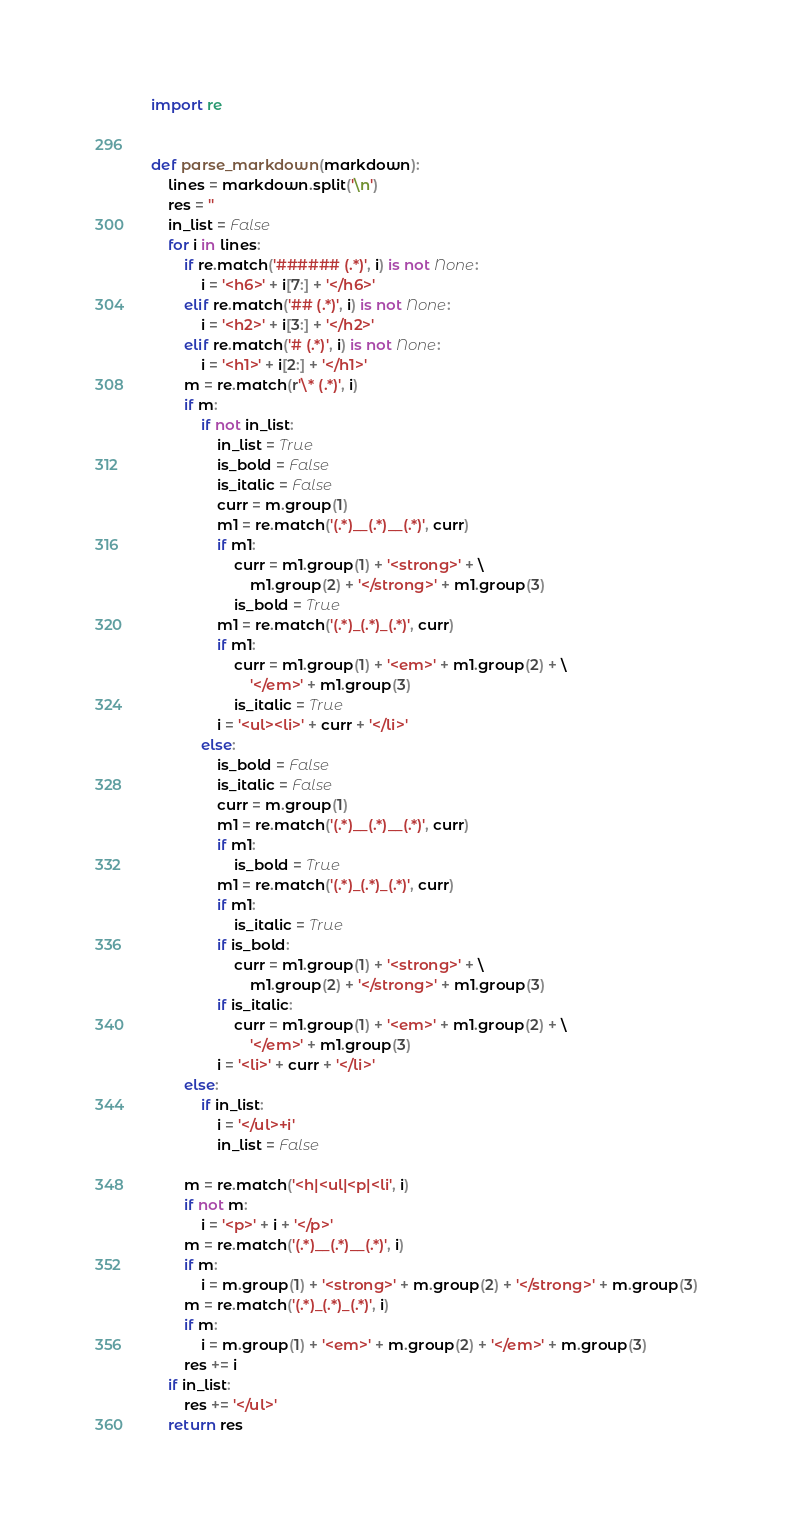Convert code to text. <code><loc_0><loc_0><loc_500><loc_500><_Python_>import re


def parse_markdown(markdown):
    lines = markdown.split('\n')
    res = ''
    in_list = False
    for i in lines:
        if re.match('###### (.*)', i) is not None:
            i = '<h6>' + i[7:] + '</h6>'
        elif re.match('## (.*)', i) is not None:
            i = '<h2>' + i[3:] + '</h2>'
        elif re.match('# (.*)', i) is not None:
            i = '<h1>' + i[2:] + '</h1>'
        m = re.match(r'\* (.*)', i)
        if m:
            if not in_list:
                in_list = True
                is_bold = False
                is_italic = False
                curr = m.group(1)
                m1 = re.match('(.*)__(.*)__(.*)', curr)
                if m1:
                    curr = m1.group(1) + '<strong>' + \
                        m1.group(2) + '</strong>' + m1.group(3)
                    is_bold = True
                m1 = re.match('(.*)_(.*)_(.*)', curr)
                if m1:
                    curr = m1.group(1) + '<em>' + m1.group(2) + \
                        '</em>' + m1.group(3)
                    is_italic = True
                i = '<ul><li>' + curr + '</li>'
            else:
                is_bold = False
                is_italic = False
                curr = m.group(1)
                m1 = re.match('(.*)__(.*)__(.*)', curr)
                if m1:
                    is_bold = True
                m1 = re.match('(.*)_(.*)_(.*)', curr)
                if m1:
                    is_italic = True
                if is_bold:
                    curr = m1.group(1) + '<strong>' + \
                        m1.group(2) + '</strong>' + m1.group(3)
                if is_italic:
                    curr = m1.group(1) + '<em>' + m1.group(2) + \
                        '</em>' + m1.group(3)
                i = '<li>' + curr + '</li>'
        else:
            if in_list:
                i = '</ul>+i'
                in_list = False

        m = re.match('<h|<ul|<p|<li', i)
        if not m:
            i = '<p>' + i + '</p>'
        m = re.match('(.*)__(.*)__(.*)', i)
        if m:
            i = m.group(1) + '<strong>' + m.group(2) + '</strong>' + m.group(3)
        m = re.match('(.*)_(.*)_(.*)', i)
        if m:
            i = m.group(1) + '<em>' + m.group(2) + '</em>' + m.group(3)
        res += i
    if in_list:
        res += '</ul>'
    return res
</code> 